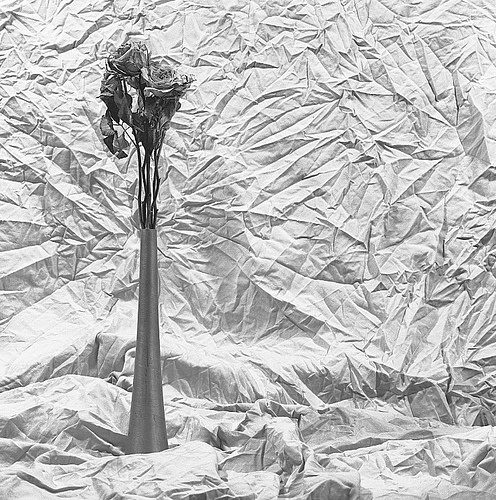Describe the objects in this image and their specific colors. I can see potted plant in whitesmoke, gray, lightgray, black, and darkgray tones and vase in whitesmoke, gray, darkgray, lightgray, and black tones in this image. 